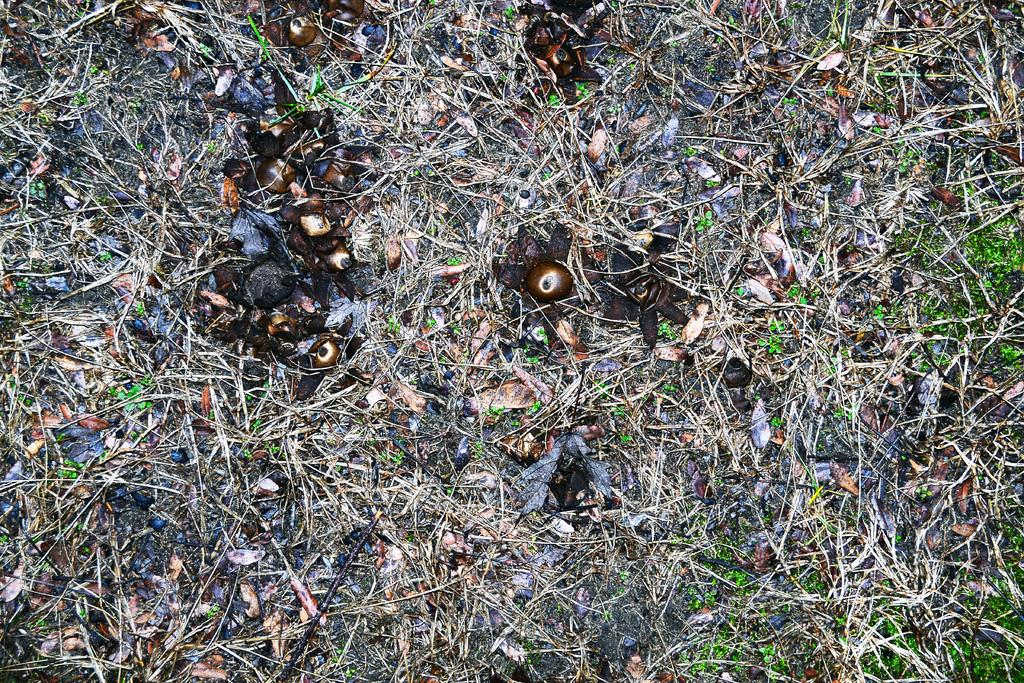What type of vegetation is visible in the image? There is grass in the image. What else can be seen in the image besides the grass? There are brown-colored things in the image. What type of plants are the friends watering on the street in the image? There is no reference to friends, watering, or a street in the image, so it's not possible to answer that question. 